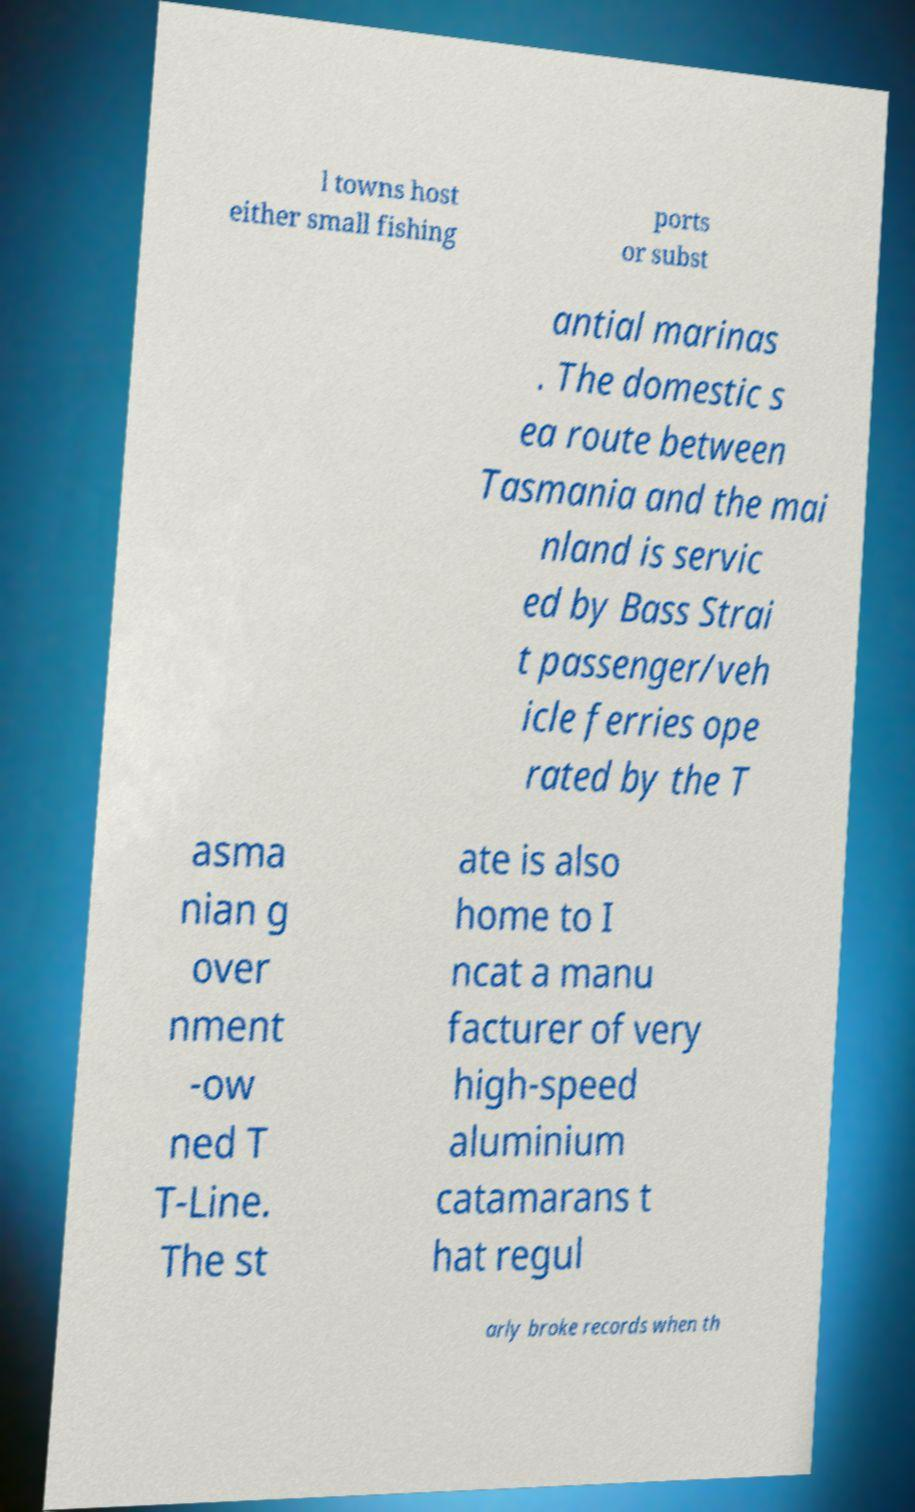Can you accurately transcribe the text from the provided image for me? l towns host either small fishing ports or subst antial marinas . The domestic s ea route between Tasmania and the mai nland is servic ed by Bass Strai t passenger/veh icle ferries ope rated by the T asma nian g over nment -ow ned T T-Line. The st ate is also home to I ncat a manu facturer of very high-speed aluminium catamarans t hat regul arly broke records when th 